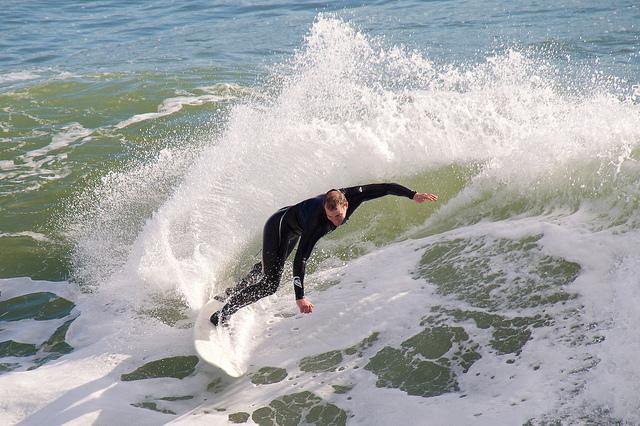Are the waves high?
Be succinct. No. Is the surfer surfing goofy foot?
Short answer required. No. Is he falling?
Give a very brief answer. No. What color is the surfboard?
Answer briefly. White. 